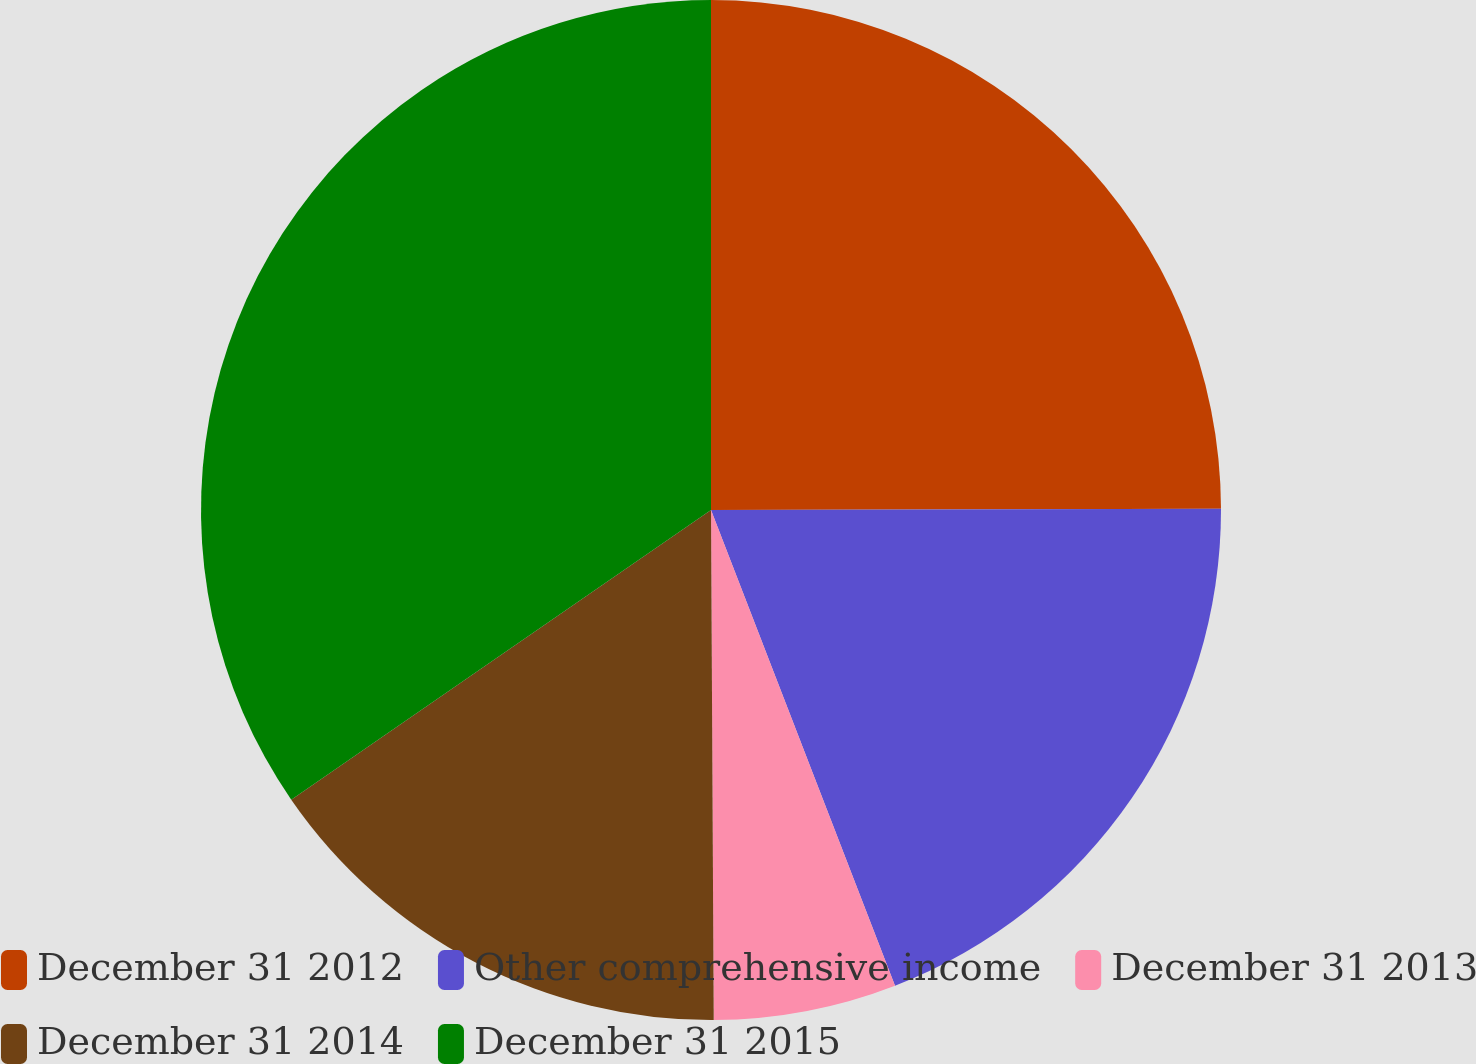Convert chart to OTSL. <chart><loc_0><loc_0><loc_500><loc_500><pie_chart><fcel>December 31 2012<fcel>Other comprehensive income<fcel>December 31 2013<fcel>December 31 2014<fcel>December 31 2015<nl><fcel>24.96%<fcel>19.16%<fcel>5.79%<fcel>15.47%<fcel>34.61%<nl></chart> 